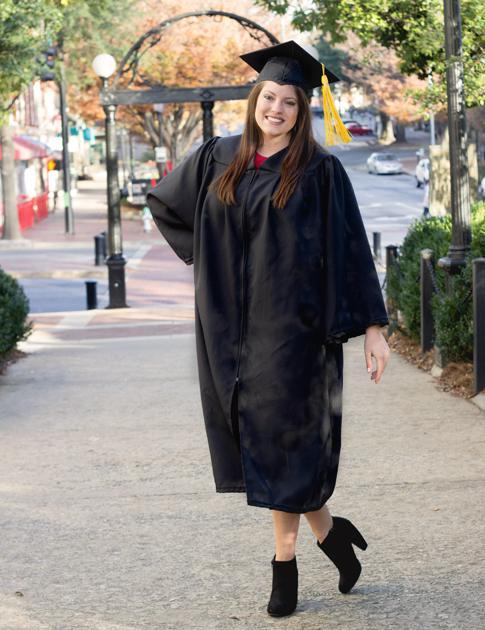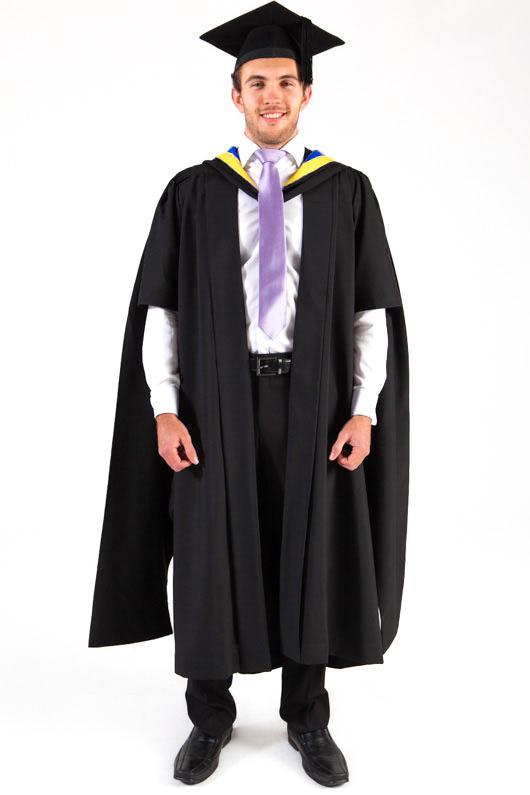The first image is the image on the left, the second image is the image on the right. For the images shown, is this caption "One of the images features an adult male wearing a black gown and purple color tie." true? Answer yes or no. Yes. 